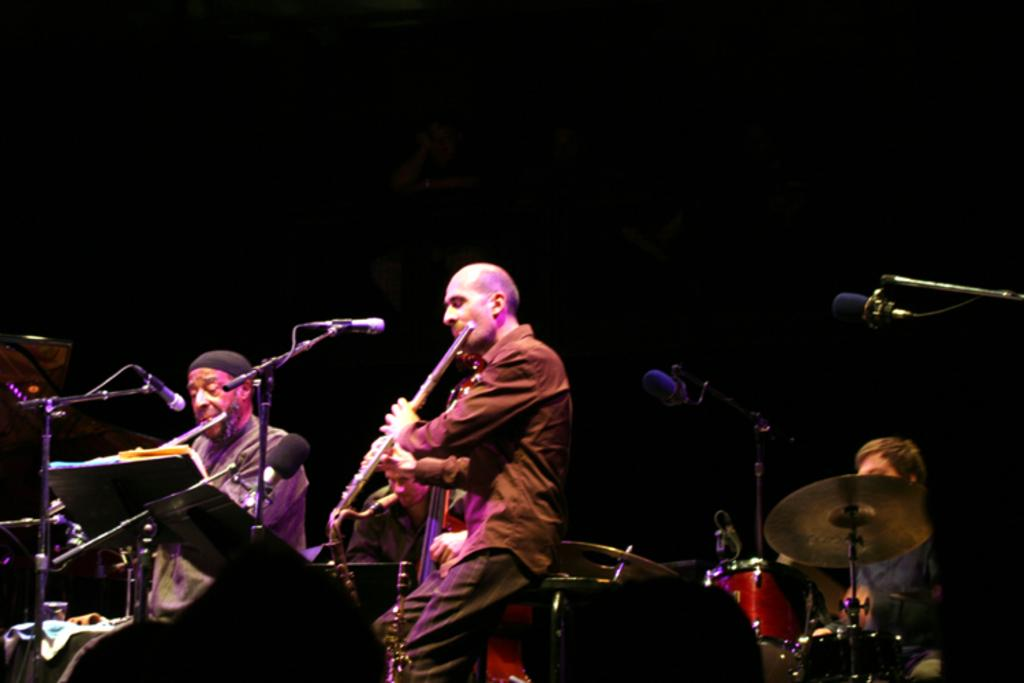What are the people in the image doing? The people in the image are playing musical instruments. What objects are present to support the musical instruments? There are mic stands in the image. What type of musical instrument can be seen in the image? There is a drum set in the image. What color is the background of the image? The background of the image is black. What type of disease is being treated by the team in the image? There is no team or disease present in the image; it features people playing musical instruments. How many tickets are visible in the image? There are no tickets present in the image. 